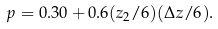<formula> <loc_0><loc_0><loc_500><loc_500>p = 0 . 3 0 + 0 . 6 ( z _ { 2 } / 6 ) ( \Delta z / 6 ) .</formula> 